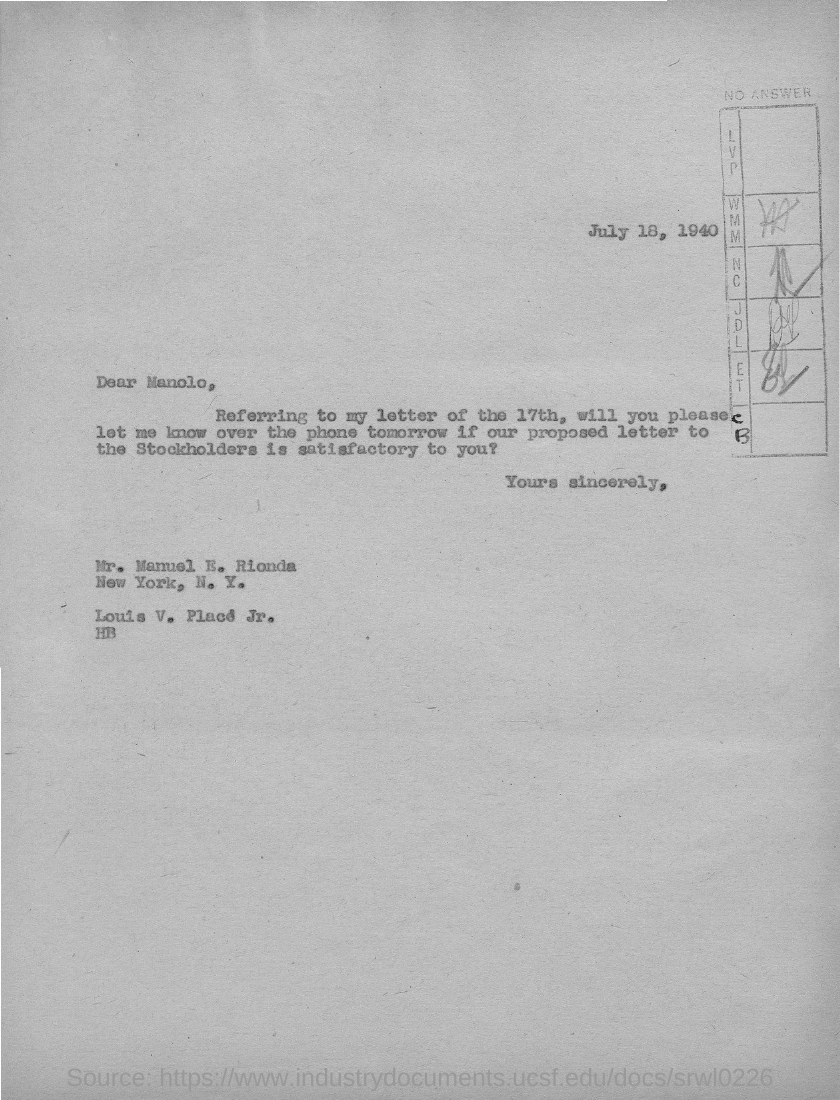When is the letter dated ?
Make the answer very short. July 18, 1940. To whom is this letter written to?
Your response must be concise. Manolo. 